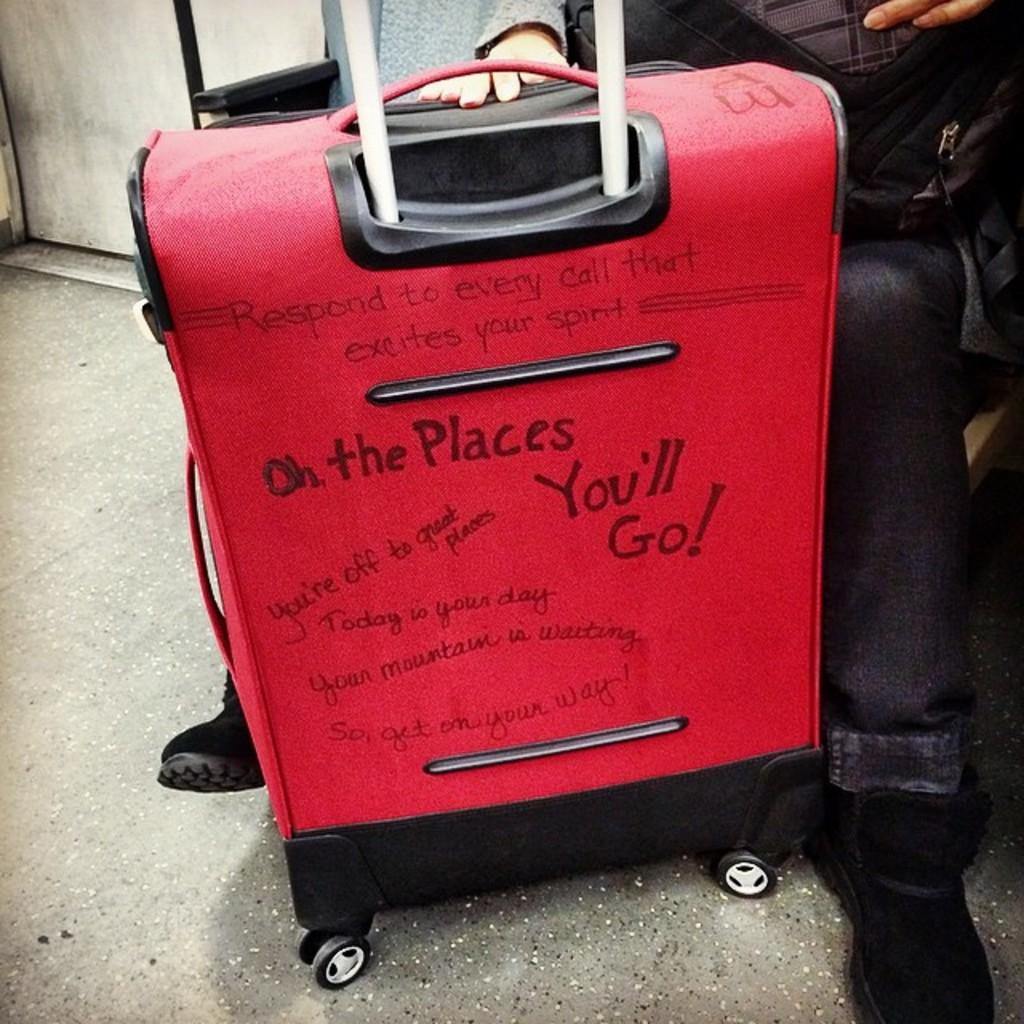What type of bag is visible in the image? There is a wheel bag in the image. Who is holding the wheel bag in the image? There is a person holding the wheel bag in the image. What type of kite is being flown by the person holding the wheel bag in the image? There is no kite present in the image; the person is only holding a wheel bag. How does the acoustics of the environment affect the person holding the wheel bag in the image? There is no information about the acoustics of the environment in the image, so it cannot be determined how it affects the person holding the wheel bag. 